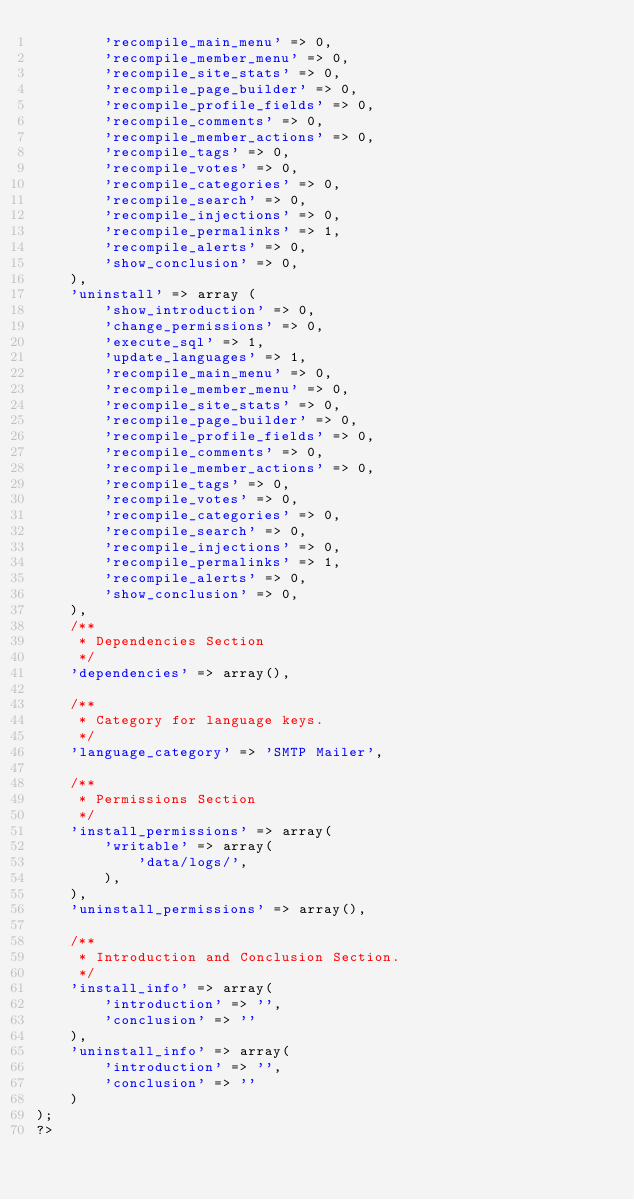Convert code to text. <code><loc_0><loc_0><loc_500><loc_500><_PHP_>		'recompile_main_menu' => 0,
		'recompile_member_menu' => 0,
        'recompile_site_stats' => 0,		
		'recompile_page_builder' => 0,
		'recompile_profile_fields' => 0,
		'recompile_comments' => 0,
		'recompile_member_actions' => 0,
		'recompile_tags' => 0,
		'recompile_votes' => 0,
		'recompile_categories' => 0,
		'recompile_search' => 0,
		'recompile_injections' => 0,
		'recompile_permalinks' => 1,
		'recompile_alerts' => 0,
		'show_conclusion' => 0,
	),
	'uninstall' => array (
		'show_introduction' => 0,
		'change_permissions' => 0,
		'execute_sql' => 1,
		'update_languages' => 1,
		'recompile_main_menu' => 0,
		'recompile_member_menu' => 0,
		'recompile_site_stats' => 0,
		'recompile_page_builder' => 0,
		'recompile_profile_fields' => 0,
		'recompile_comments' => 0,
		'recompile_member_actions' => 0,
		'recompile_tags' => 0,
		'recompile_votes' => 0,
		'recompile_categories' => 0,
		'recompile_search' => 0,
		'recompile_injections' => 0,
		'recompile_permalinks' => 1,
		'recompile_alerts' => 0,
		'show_conclusion' => 0,
    ),
    /**
	 * Dependencies Section
	 */
	'dependencies' => array(),

	/**
	 * Category for language keys.
	 */
	'language_category' => 'SMTP Mailer',

	/**
	 * Permissions Section
	 */
    'install_permissions' => array(
        'writable' => array(
            'data/logs/',
        ),
    ),
    'uninstall_permissions' => array(),

	/**
	 * Introduction and Conclusion Section.
	 */
	'install_info' => array(
		'introduction' => '',
		'conclusion' => ''
	),
	'uninstall_info' => array(
		'introduction' => '',
		'conclusion' => ''
	)
);
?>
</code> 